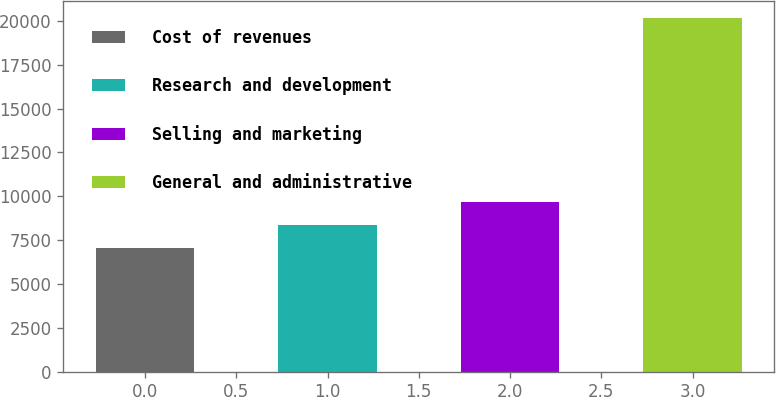<chart> <loc_0><loc_0><loc_500><loc_500><bar_chart><fcel>Cost of revenues<fcel>Research and development<fcel>Selling and marketing<fcel>General and administrative<nl><fcel>7031<fcel>8343.2<fcel>9655.4<fcel>20153<nl></chart> 